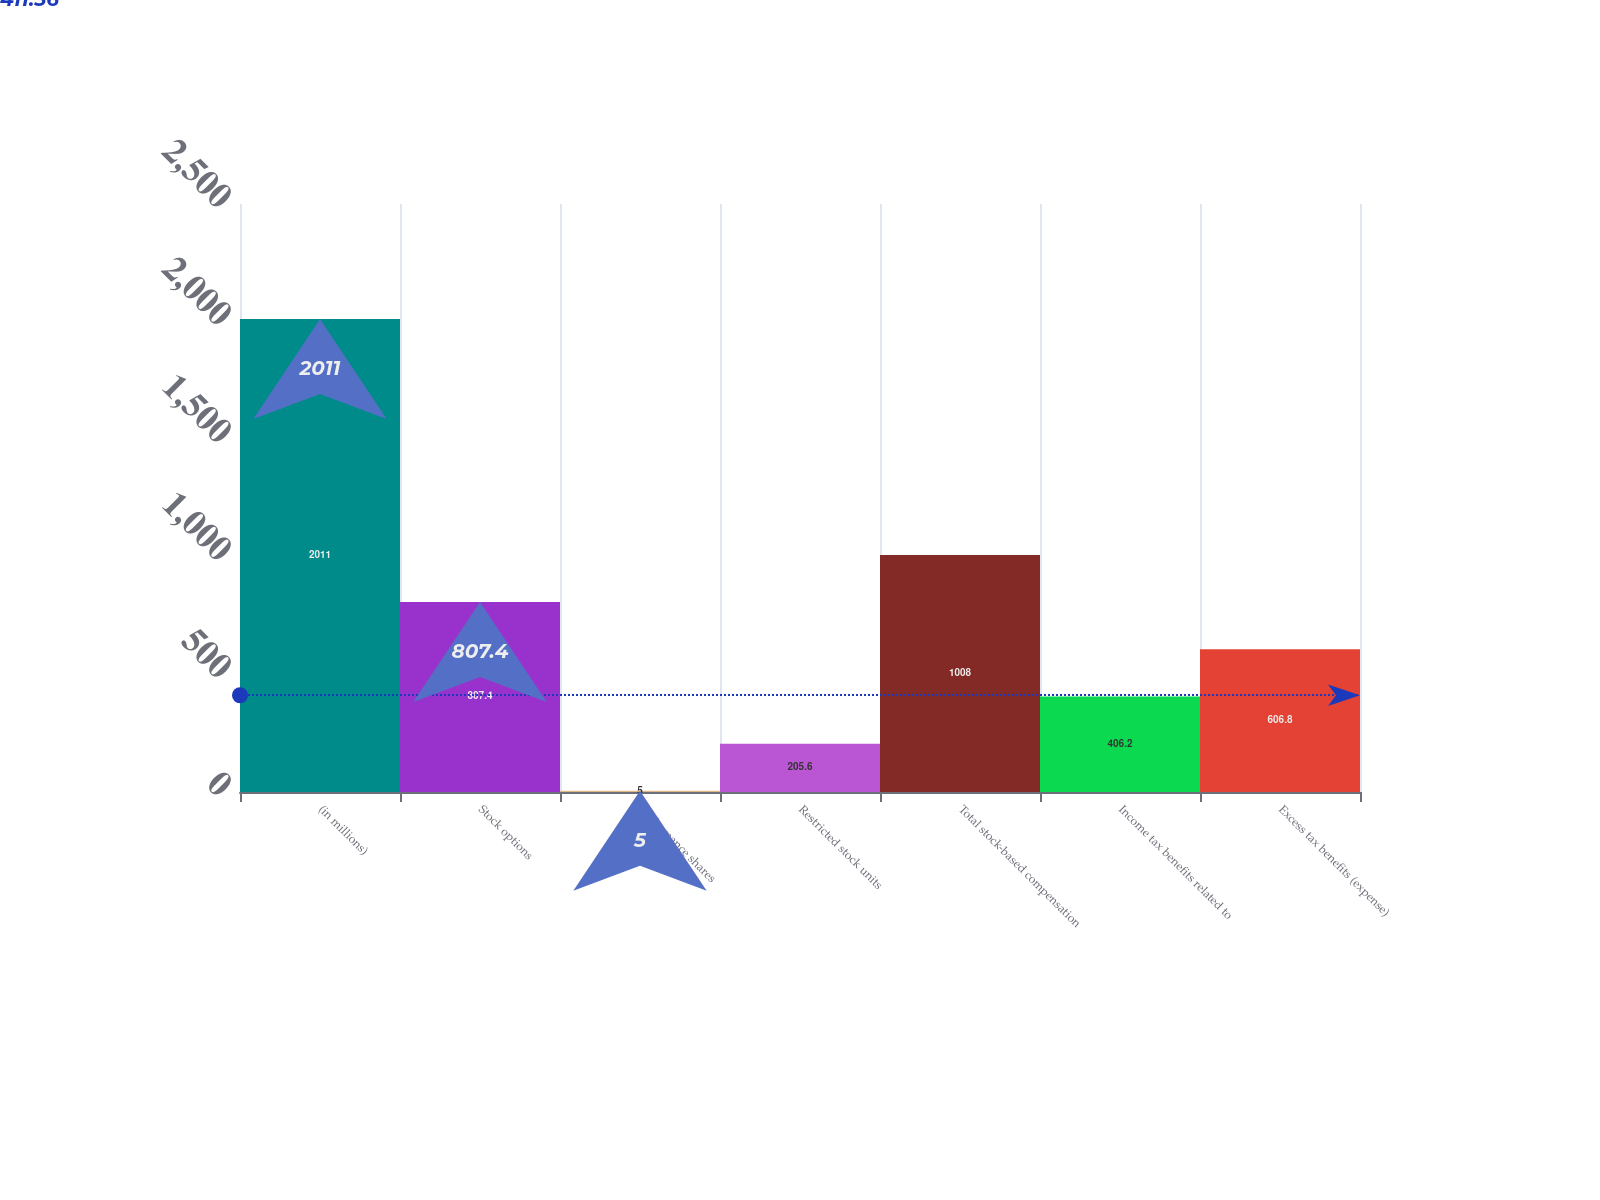<chart> <loc_0><loc_0><loc_500><loc_500><bar_chart><fcel>(in millions)<fcel>Stock options<fcel>Performance shares<fcel>Restricted stock units<fcel>Total stock-based compensation<fcel>Income tax benefits related to<fcel>Excess tax benefits (expense)<nl><fcel>2011<fcel>807.4<fcel>5<fcel>205.6<fcel>1008<fcel>406.2<fcel>606.8<nl></chart> 